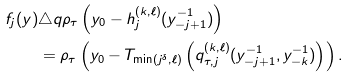<formula> <loc_0><loc_0><loc_500><loc_500>f _ { j } ( y ) & \triangle q \rho _ { \tau } \left ( y _ { 0 } - h _ { j } ^ { ( k , \ell ) } ( y _ { - j + 1 } ^ { - 1 } ) \right ) \\ & = \rho _ { \tau } \left ( y _ { 0 } - T _ { \min ( j ^ { \delta } , \ell ) } \left ( q _ { \tau , j } ^ { ( k , \ell ) } ( y _ { - j + 1 } ^ { - 1 } , y _ { - k } ^ { - 1 } ) \right ) \right ) .</formula> 